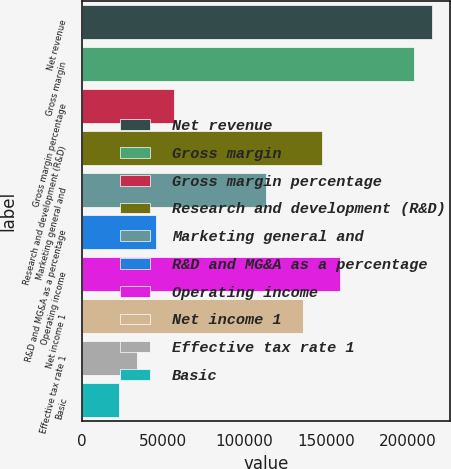Convert chart to OTSL. <chart><loc_0><loc_0><loc_500><loc_500><bar_chart><fcel>Net revenue<fcel>Gross margin<fcel>Gross margin percentage<fcel>Research and development (R&D)<fcel>Marketing general and<fcel>R&D and MG&A as a percentage<fcel>Operating income<fcel>Net income 1<fcel>Effective tax rate 1<fcel>Basic<nl><fcel>215320<fcel>203988<fcel>56664<fcel>147325<fcel>113327<fcel>45331.4<fcel>158657<fcel>135992<fcel>33998.8<fcel>22666.2<nl></chart> 